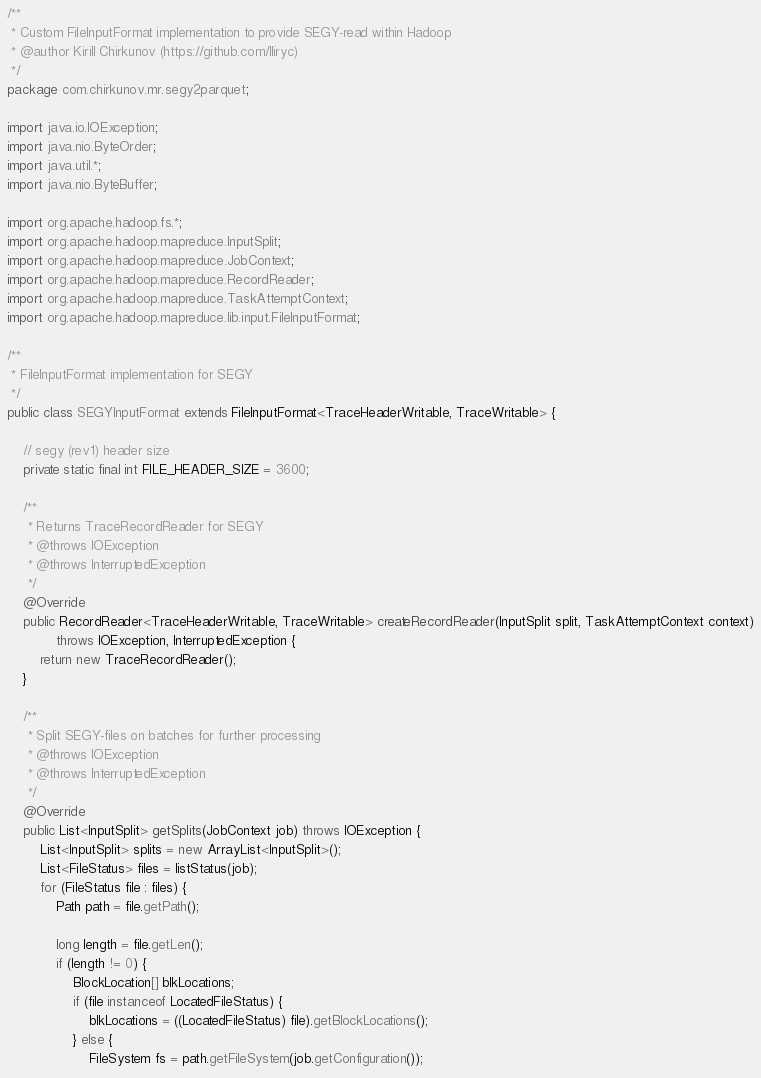<code> <loc_0><loc_0><loc_500><loc_500><_Java_>/**
 * Custom FileInputFormat implementation to provide SEGY-read within Hadoop
 * @author Kirill Chirkunov (https://github.com/lliryc)
 */
package com.chirkunov.mr.segy2parquet;

import java.io.IOException;
import java.nio.ByteOrder;
import java.util.*;
import java.nio.ByteBuffer;

import org.apache.hadoop.fs.*;
import org.apache.hadoop.mapreduce.InputSplit;
import org.apache.hadoop.mapreduce.JobContext;
import org.apache.hadoop.mapreduce.RecordReader;
import org.apache.hadoop.mapreduce.TaskAttemptContext;
import org.apache.hadoop.mapreduce.lib.input.FileInputFormat;

/**
 * FileInputFormat implementation for SEGY
 */
public class SEGYInputFormat extends FileInputFormat<TraceHeaderWritable, TraceWritable> {

	// segy (rev1) header size
	private static final int FILE_HEADER_SIZE = 3600;

	/**
	 * Returns TraceRecordReader for SEGY
	 * @throws IOException
	 * @throws InterruptedException
	 */
	@Override
	public RecordReader<TraceHeaderWritable, TraceWritable> createRecordReader(InputSplit split, TaskAttemptContext context)
			throws IOException, InterruptedException {
		return new TraceRecordReader();
	}

	/**
	 * Split SEGY-files on batches for further processing
	 * @throws IOException
	 * @throws InterruptedException
	 */
	@Override
	public List<InputSplit> getSplits(JobContext job) throws IOException {
		List<InputSplit> splits = new ArrayList<InputSplit>();
		List<FileStatus> files = listStatus(job);
		for (FileStatus file : files) {
			Path path = file.getPath();

			long length = file.getLen();
			if (length != 0) {
				BlockLocation[] blkLocations;
				if (file instanceof LocatedFileStatus) {
					blkLocations = ((LocatedFileStatus) file).getBlockLocations();
				} else {
					FileSystem fs = path.getFileSystem(job.getConfiguration());</code> 